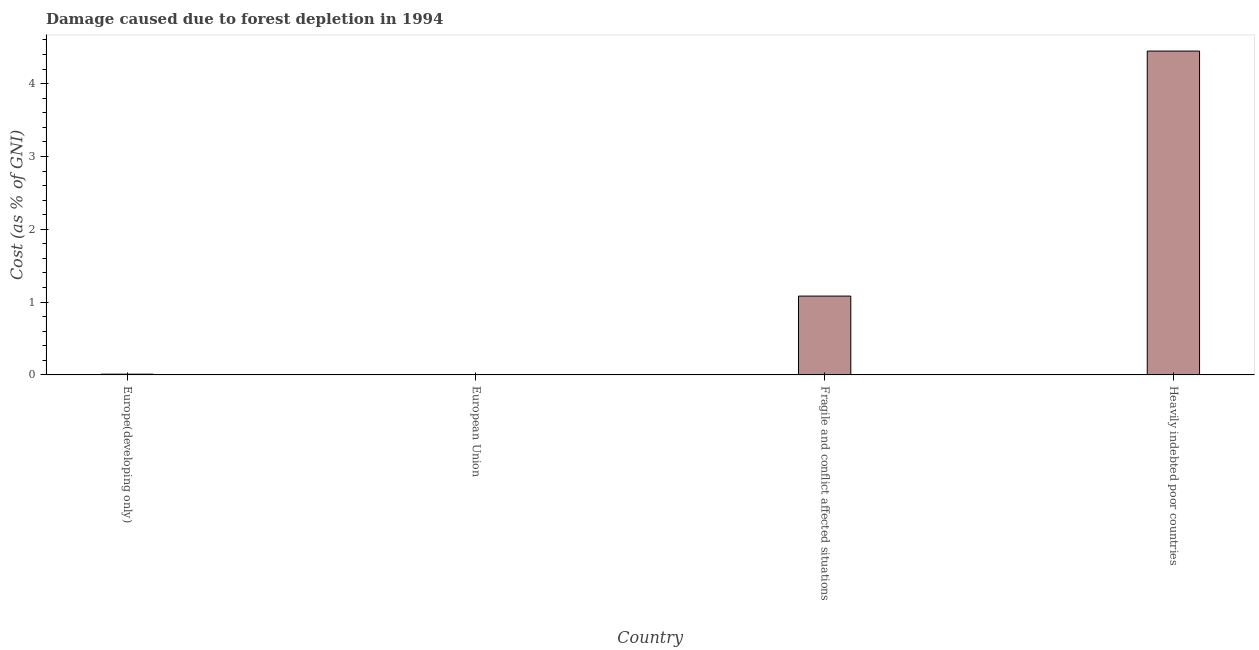Does the graph contain any zero values?
Keep it short and to the point. No. Does the graph contain grids?
Give a very brief answer. No. What is the title of the graph?
Provide a short and direct response. Damage caused due to forest depletion in 1994. What is the label or title of the X-axis?
Your response must be concise. Country. What is the label or title of the Y-axis?
Provide a succinct answer. Cost (as % of GNI). What is the damage caused due to forest depletion in Europe(developing only)?
Keep it short and to the point. 0.01. Across all countries, what is the maximum damage caused due to forest depletion?
Your answer should be compact. 4.45. Across all countries, what is the minimum damage caused due to forest depletion?
Offer a very short reply. 0. In which country was the damage caused due to forest depletion maximum?
Keep it short and to the point. Heavily indebted poor countries. In which country was the damage caused due to forest depletion minimum?
Offer a terse response. European Union. What is the sum of the damage caused due to forest depletion?
Ensure brevity in your answer.  5.54. What is the difference between the damage caused due to forest depletion in European Union and Heavily indebted poor countries?
Your response must be concise. -4.45. What is the average damage caused due to forest depletion per country?
Give a very brief answer. 1.39. What is the median damage caused due to forest depletion?
Offer a terse response. 0.55. Is the damage caused due to forest depletion in European Union less than that in Heavily indebted poor countries?
Give a very brief answer. Yes. What is the difference between the highest and the second highest damage caused due to forest depletion?
Give a very brief answer. 3.37. Is the sum of the damage caused due to forest depletion in European Union and Heavily indebted poor countries greater than the maximum damage caused due to forest depletion across all countries?
Your answer should be very brief. Yes. What is the difference between the highest and the lowest damage caused due to forest depletion?
Provide a succinct answer. 4.45. How many bars are there?
Your response must be concise. 4. Are all the bars in the graph horizontal?
Provide a short and direct response. No. How many countries are there in the graph?
Provide a succinct answer. 4. What is the difference between two consecutive major ticks on the Y-axis?
Offer a very short reply. 1. What is the Cost (as % of GNI) of Europe(developing only)?
Your response must be concise. 0.01. What is the Cost (as % of GNI) of European Union?
Your answer should be compact. 0. What is the Cost (as % of GNI) in Fragile and conflict affected situations?
Your answer should be compact. 1.08. What is the Cost (as % of GNI) in Heavily indebted poor countries?
Your response must be concise. 4.45. What is the difference between the Cost (as % of GNI) in Europe(developing only) and European Union?
Your answer should be very brief. 0.01. What is the difference between the Cost (as % of GNI) in Europe(developing only) and Fragile and conflict affected situations?
Your response must be concise. -1.07. What is the difference between the Cost (as % of GNI) in Europe(developing only) and Heavily indebted poor countries?
Ensure brevity in your answer.  -4.44. What is the difference between the Cost (as % of GNI) in European Union and Fragile and conflict affected situations?
Ensure brevity in your answer.  -1.08. What is the difference between the Cost (as % of GNI) in European Union and Heavily indebted poor countries?
Offer a terse response. -4.45. What is the difference between the Cost (as % of GNI) in Fragile and conflict affected situations and Heavily indebted poor countries?
Your answer should be compact. -3.37. What is the ratio of the Cost (as % of GNI) in Europe(developing only) to that in European Union?
Ensure brevity in your answer.  5.35. What is the ratio of the Cost (as % of GNI) in Europe(developing only) to that in Fragile and conflict affected situations?
Offer a very short reply. 0.01. What is the ratio of the Cost (as % of GNI) in Europe(developing only) to that in Heavily indebted poor countries?
Ensure brevity in your answer.  0. What is the ratio of the Cost (as % of GNI) in European Union to that in Fragile and conflict affected situations?
Offer a terse response. 0. What is the ratio of the Cost (as % of GNI) in Fragile and conflict affected situations to that in Heavily indebted poor countries?
Keep it short and to the point. 0.24. 